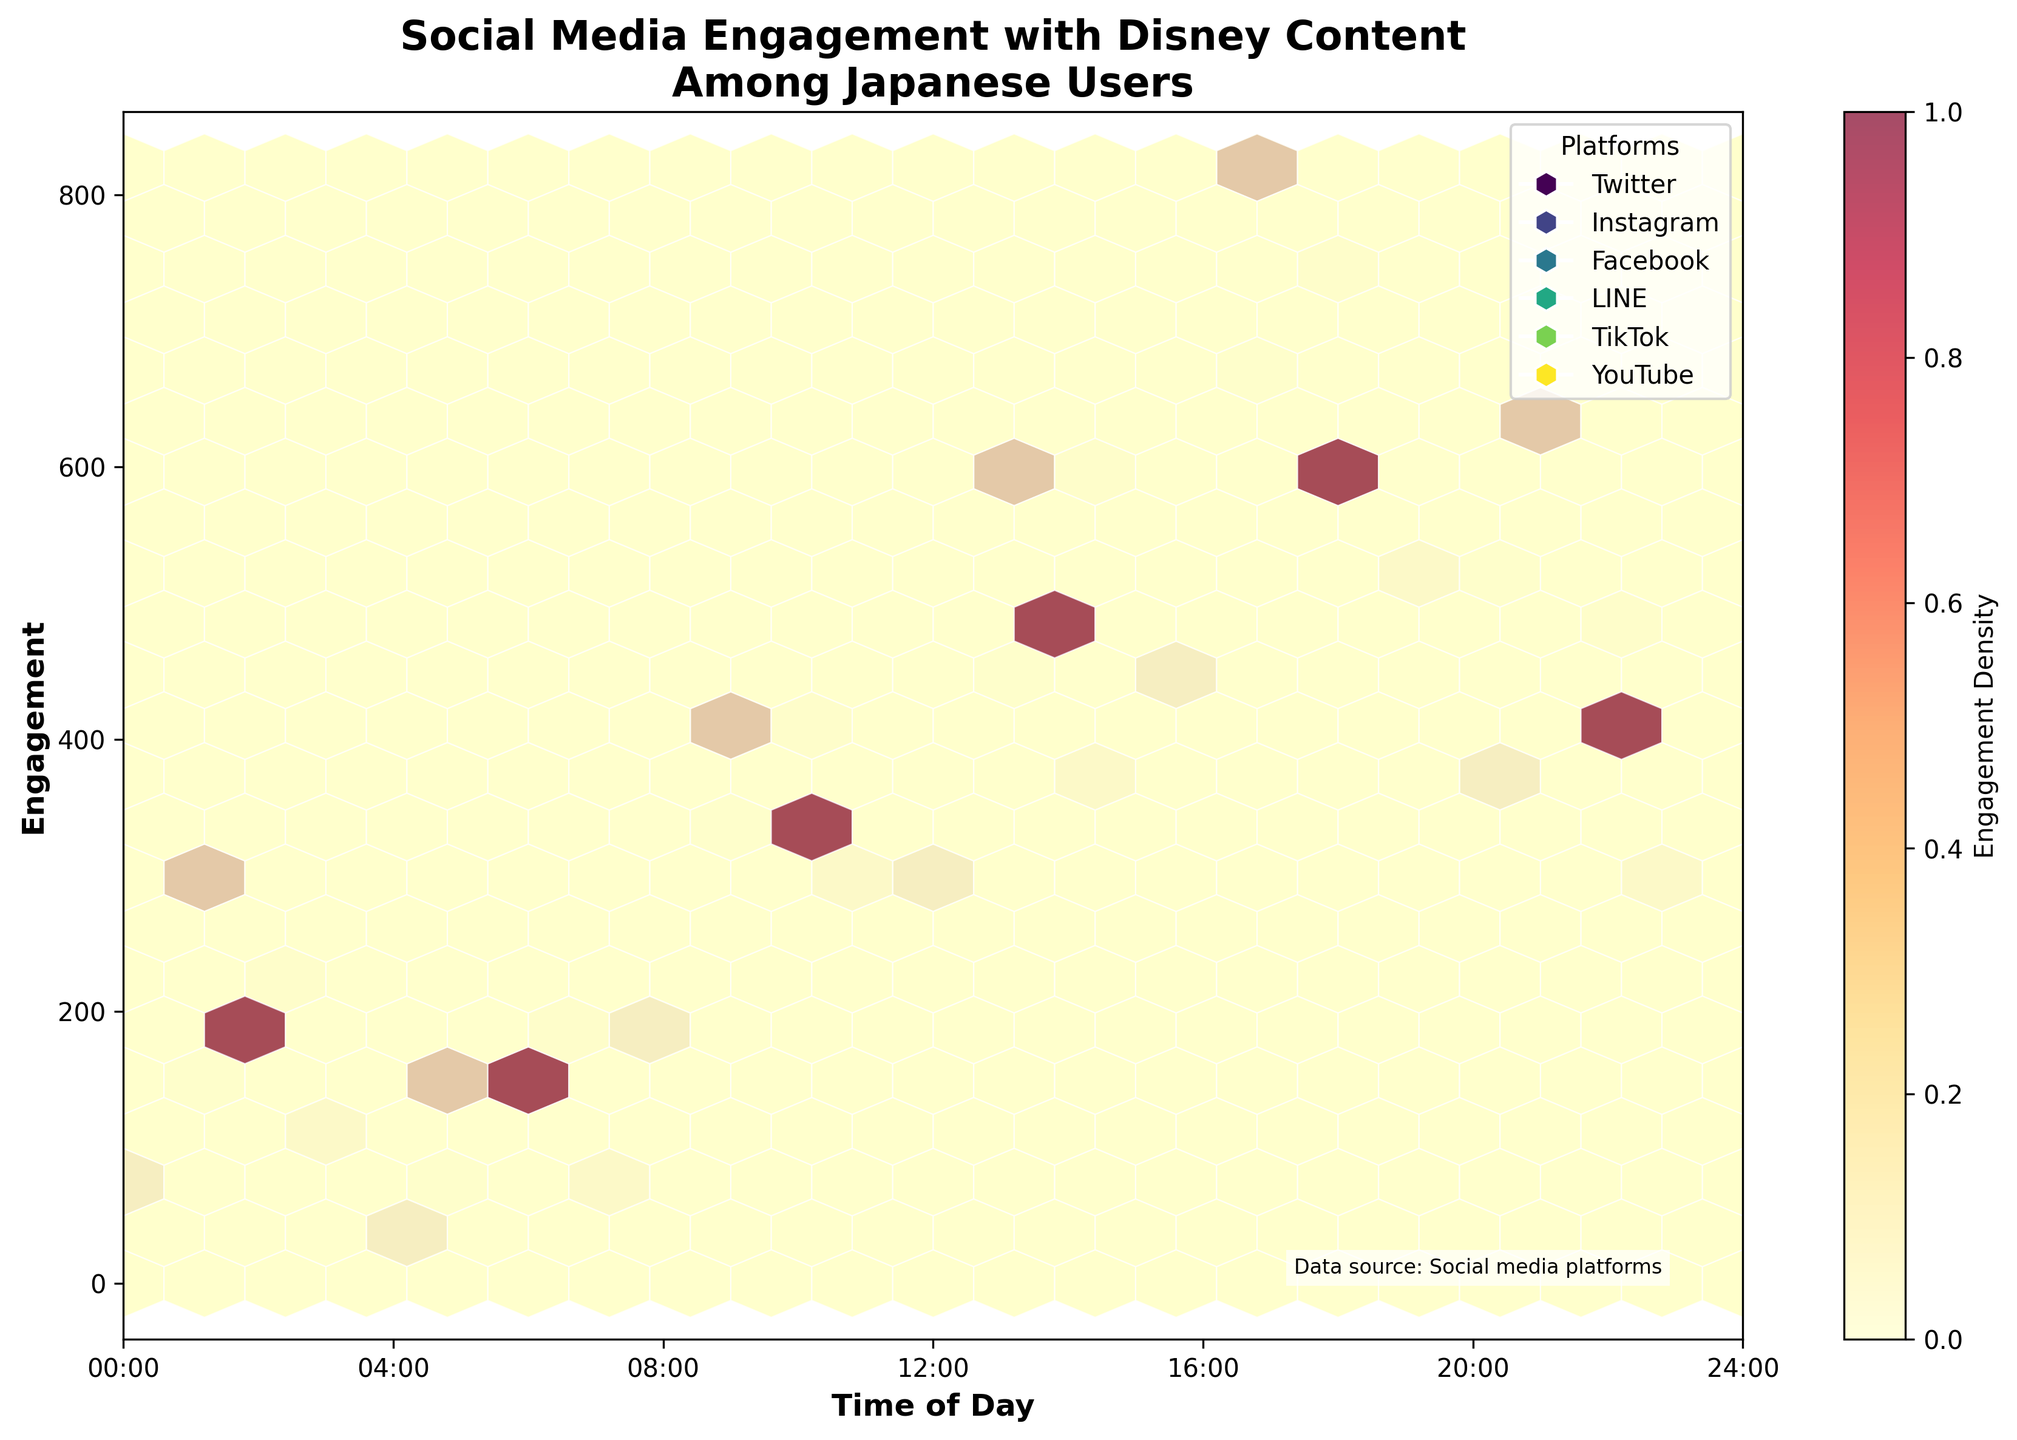What is the title of the plot? The title can be found at the top of the plot and it summarizes the main topic of the figure.
Answer: Social Media Engagement with Disney Content Among Japanese Users What times of day are shown on the x-axis? Look at the x-axis labels to find the range of times displayed. The x-axis typically represents time from 0 to 24 hours.
Answer: 0:00 - 24:00 Which platform has the highest engagement density in the hexbin plot? Engagement density can be gauged by the color intensity in the hexbin plot. Look for the platform with the darkest (densest) hexagons.
Answer: TikTok At what time of day does Instagram reach its peak engagement? Identify the hexagons associated with Instagram and look for the highest engagement value along the y-axis. Then, find the corresponding x-axis value.
Answer: 18:00 What times show the lowest engagement for Twitter? Observe the hexagons for Twitter and note when the engagement values are at their minimum along the y-axis. Refer to the corresponding time on the x-axis.
Answer: 05:00 Compare overall engagement trends between Facebook and LINE. Which platform tends to have higher engagement overall? Visually compare the hexagons of Facebook and LINE across different times of the day, focusing on the height and density of the hexagons.
Answer: Facebook Which platform shows a more even distribution of engagement across different times of the day? Look for platforms with consistently spaced hexagons that are similar in color density across different times on the x-axis.
Answer: YouTube During which time of day is social media engagement the most diverse across platforms? Identify the time when multiple platforms display high engagement values (dense hexagons) together on the plot.
Answer: 13:00 - 18:00 What is the range of engagement values shown on the y-axis? The y-axis represents engagement values. Check the minimum and maximum values displayed.
Answer: 50 - 820 Compare the engagement trends of Instagram and YouTube. Which platform has a sharper increase in engagement during the day? Observe the rise in hexagon heights for both platforms as time progresses from morning to evening, noting which has a steeper slope.
Answer: Instagram 